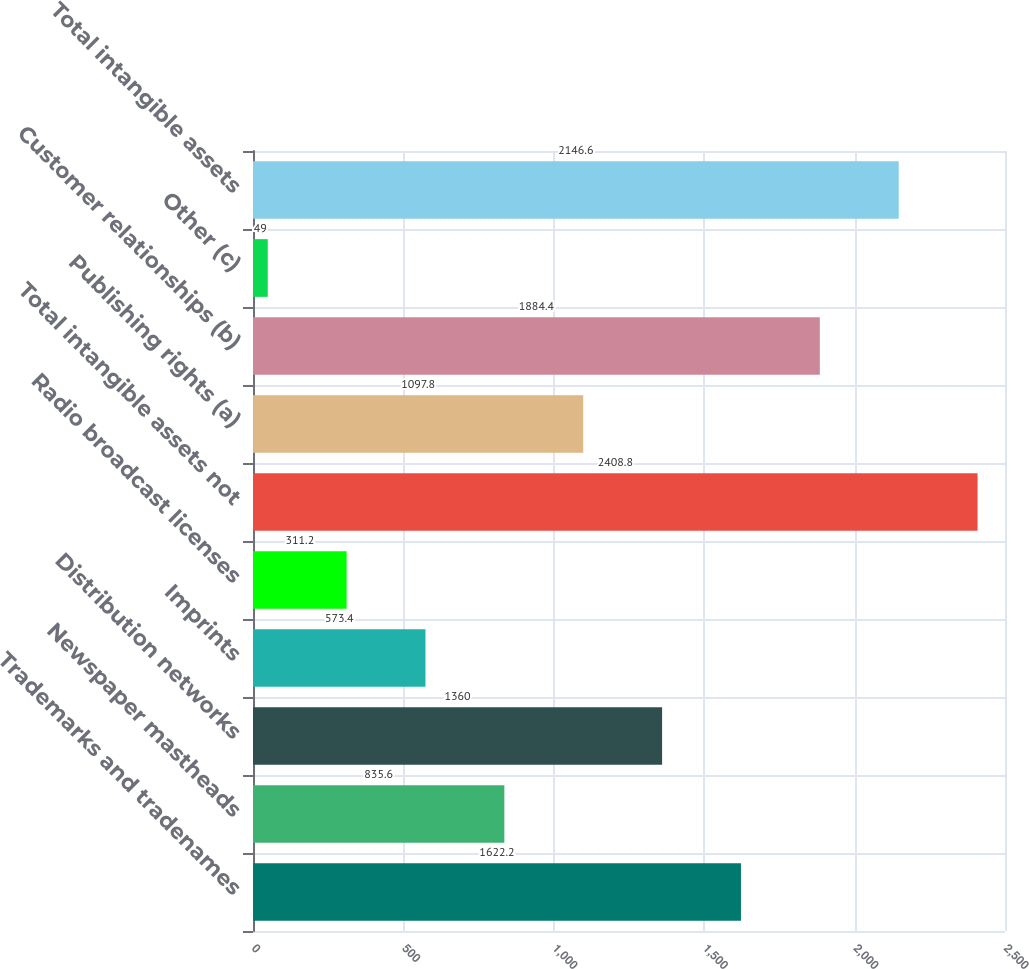Convert chart. <chart><loc_0><loc_0><loc_500><loc_500><bar_chart><fcel>Trademarks and tradenames<fcel>Newspaper mastheads<fcel>Distribution networks<fcel>Imprints<fcel>Radio broadcast licenses<fcel>Total intangible assets not<fcel>Publishing rights (a)<fcel>Customer relationships (b)<fcel>Other (c)<fcel>Total intangible assets<nl><fcel>1622.2<fcel>835.6<fcel>1360<fcel>573.4<fcel>311.2<fcel>2408.8<fcel>1097.8<fcel>1884.4<fcel>49<fcel>2146.6<nl></chart> 